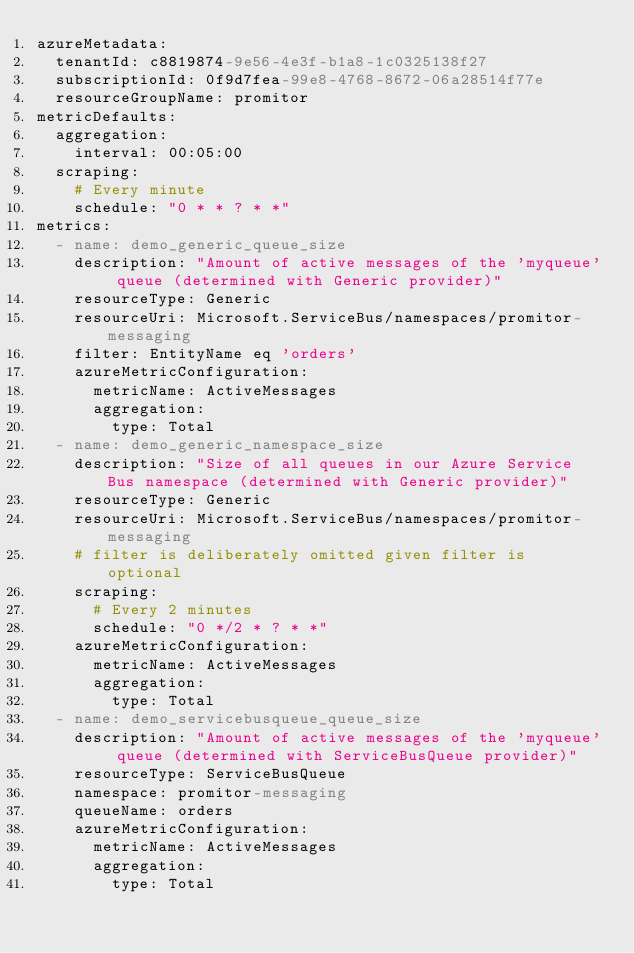<code> <loc_0><loc_0><loc_500><loc_500><_YAML_>azureMetadata:
  tenantId: c8819874-9e56-4e3f-b1a8-1c0325138f27
  subscriptionId: 0f9d7fea-99e8-4768-8672-06a28514f77e
  resourceGroupName: promitor
metricDefaults:
  aggregation:
    interval: 00:05:00
  scraping:
    # Every minute
    schedule: "0 * * ? * *"
metrics:
  - name: demo_generic_queue_size
    description: "Amount of active messages of the 'myqueue' queue (determined with Generic provider)"
    resourceType: Generic
    resourceUri: Microsoft.ServiceBus/namespaces/promitor-messaging
    filter: EntityName eq 'orders'
    azureMetricConfiguration:
      metricName: ActiveMessages
      aggregation:
        type: Total
  - name: demo_generic_namespace_size
    description: "Size of all queues in our Azure Service Bus namespace (determined with Generic provider)"
    resourceType: Generic
    resourceUri: Microsoft.ServiceBus/namespaces/promitor-messaging
    # filter is deliberately omitted given filter is optional
    scraping:
      # Every 2 minutes
      schedule: "0 */2 * ? * *"
    azureMetricConfiguration:
      metricName: ActiveMessages
      aggregation:
        type: Total
  - name: demo_servicebusqueue_queue_size
    description: "Amount of active messages of the 'myqueue' queue (determined with ServiceBusQueue provider)"
    resourceType: ServiceBusQueue
    namespace: promitor-messaging
    queueName: orders
    azureMetricConfiguration:
      metricName: ActiveMessages
      aggregation:
        type: Total</code> 